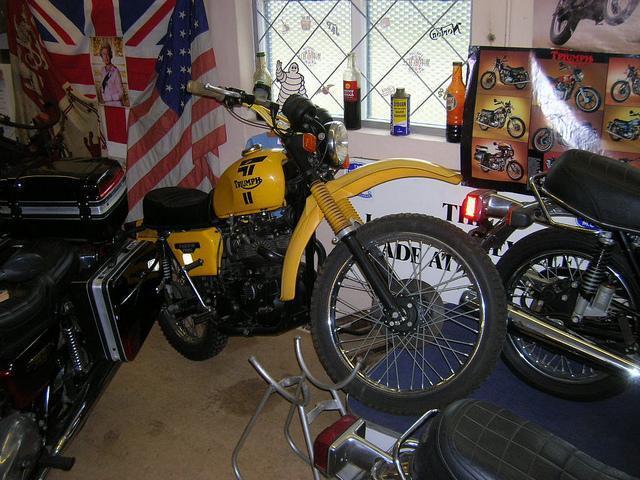How many bikes are in the photo?
Give a very brief answer. 2. How many bikes are in this area?
Give a very brief answer. 2. How many motorcycles can you see?
Give a very brief answer. 4. How many suitcases are there?
Give a very brief answer. 2. 